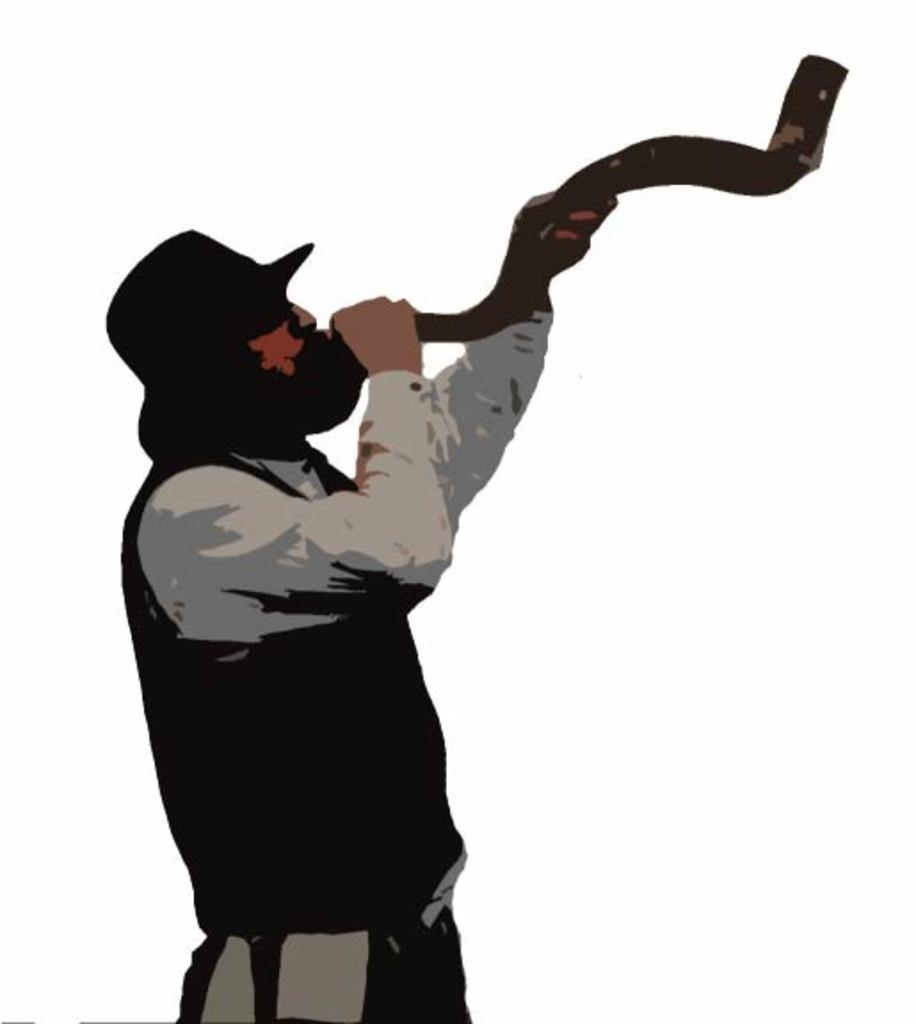What is present in the image? There is a person in the image. What is the person doing in the image? The person is holding an object in his hands. What type of coast can be seen in the image? There is no coast present in the image; it only features a person holding an object. What is the weather like in the image, considering it's winter? The provided facts do not mention any information about the weather or season, so we cannot determine if it's winter or if the weather is related to the image. 